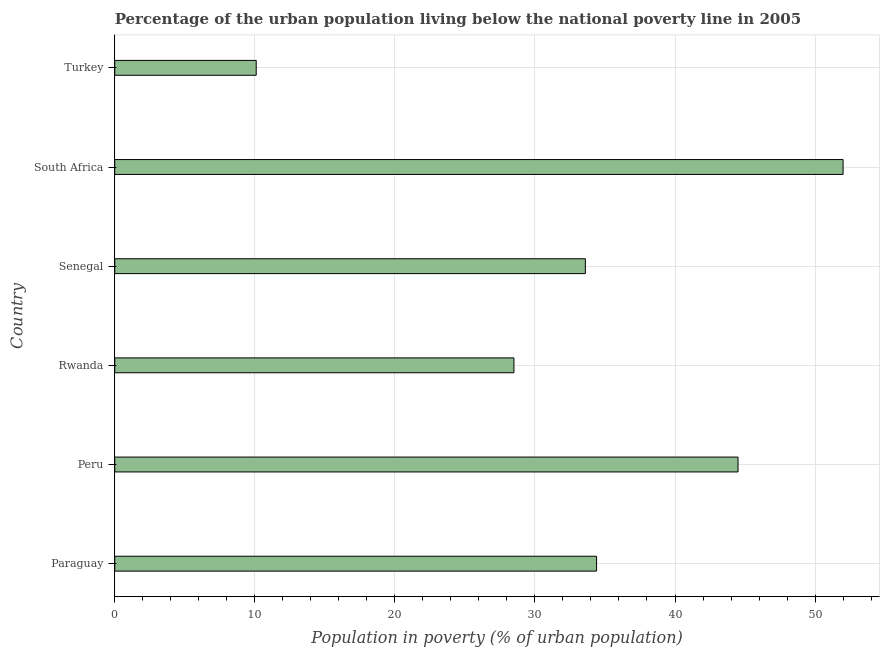What is the title of the graph?
Your answer should be compact. Percentage of the urban population living below the national poverty line in 2005. What is the label or title of the X-axis?
Provide a short and direct response. Population in poverty (% of urban population). What is the label or title of the Y-axis?
Give a very brief answer. Country. What is the percentage of urban population living below poverty line in Peru?
Give a very brief answer. 44.5. Across all countries, what is the minimum percentage of urban population living below poverty line?
Provide a short and direct response. 10.1. In which country was the percentage of urban population living below poverty line maximum?
Offer a terse response. South Africa. In which country was the percentage of urban population living below poverty line minimum?
Keep it short and to the point. Turkey. What is the sum of the percentage of urban population living below poverty line?
Give a very brief answer. 203.1. What is the difference between the percentage of urban population living below poverty line in Senegal and South Africa?
Offer a terse response. -18.4. What is the average percentage of urban population living below poverty line per country?
Your response must be concise. 33.85. What is the ratio of the percentage of urban population living below poverty line in Rwanda to that in South Africa?
Your answer should be very brief. 0.55. What is the difference between the highest and the second highest percentage of urban population living below poverty line?
Give a very brief answer. 7.5. What is the difference between the highest and the lowest percentage of urban population living below poverty line?
Provide a succinct answer. 41.9. In how many countries, is the percentage of urban population living below poverty line greater than the average percentage of urban population living below poverty line taken over all countries?
Give a very brief answer. 3. Are all the bars in the graph horizontal?
Ensure brevity in your answer.  Yes. How many countries are there in the graph?
Your answer should be compact. 6. Are the values on the major ticks of X-axis written in scientific E-notation?
Provide a succinct answer. No. What is the Population in poverty (% of urban population) in Paraguay?
Offer a terse response. 34.4. What is the Population in poverty (% of urban population) of Peru?
Make the answer very short. 44.5. What is the Population in poverty (% of urban population) in Senegal?
Provide a succinct answer. 33.6. What is the Population in poverty (% of urban population) of South Africa?
Keep it short and to the point. 52. What is the difference between the Population in poverty (% of urban population) in Paraguay and South Africa?
Your response must be concise. -17.6. What is the difference between the Population in poverty (% of urban population) in Paraguay and Turkey?
Keep it short and to the point. 24.3. What is the difference between the Population in poverty (% of urban population) in Peru and Rwanda?
Keep it short and to the point. 16. What is the difference between the Population in poverty (% of urban population) in Peru and South Africa?
Ensure brevity in your answer.  -7.5. What is the difference between the Population in poverty (% of urban population) in Peru and Turkey?
Your response must be concise. 34.4. What is the difference between the Population in poverty (% of urban population) in Rwanda and Senegal?
Provide a short and direct response. -5.1. What is the difference between the Population in poverty (% of urban population) in Rwanda and South Africa?
Offer a terse response. -23.5. What is the difference between the Population in poverty (% of urban population) in Senegal and South Africa?
Provide a short and direct response. -18.4. What is the difference between the Population in poverty (% of urban population) in Senegal and Turkey?
Offer a terse response. 23.5. What is the difference between the Population in poverty (% of urban population) in South Africa and Turkey?
Make the answer very short. 41.9. What is the ratio of the Population in poverty (% of urban population) in Paraguay to that in Peru?
Make the answer very short. 0.77. What is the ratio of the Population in poverty (% of urban population) in Paraguay to that in Rwanda?
Provide a succinct answer. 1.21. What is the ratio of the Population in poverty (% of urban population) in Paraguay to that in Senegal?
Make the answer very short. 1.02. What is the ratio of the Population in poverty (% of urban population) in Paraguay to that in South Africa?
Ensure brevity in your answer.  0.66. What is the ratio of the Population in poverty (% of urban population) in Paraguay to that in Turkey?
Your response must be concise. 3.41. What is the ratio of the Population in poverty (% of urban population) in Peru to that in Rwanda?
Make the answer very short. 1.56. What is the ratio of the Population in poverty (% of urban population) in Peru to that in Senegal?
Ensure brevity in your answer.  1.32. What is the ratio of the Population in poverty (% of urban population) in Peru to that in South Africa?
Your response must be concise. 0.86. What is the ratio of the Population in poverty (% of urban population) in Peru to that in Turkey?
Your response must be concise. 4.41. What is the ratio of the Population in poverty (% of urban population) in Rwanda to that in Senegal?
Provide a succinct answer. 0.85. What is the ratio of the Population in poverty (% of urban population) in Rwanda to that in South Africa?
Make the answer very short. 0.55. What is the ratio of the Population in poverty (% of urban population) in Rwanda to that in Turkey?
Your response must be concise. 2.82. What is the ratio of the Population in poverty (% of urban population) in Senegal to that in South Africa?
Provide a succinct answer. 0.65. What is the ratio of the Population in poverty (% of urban population) in Senegal to that in Turkey?
Make the answer very short. 3.33. What is the ratio of the Population in poverty (% of urban population) in South Africa to that in Turkey?
Make the answer very short. 5.15. 